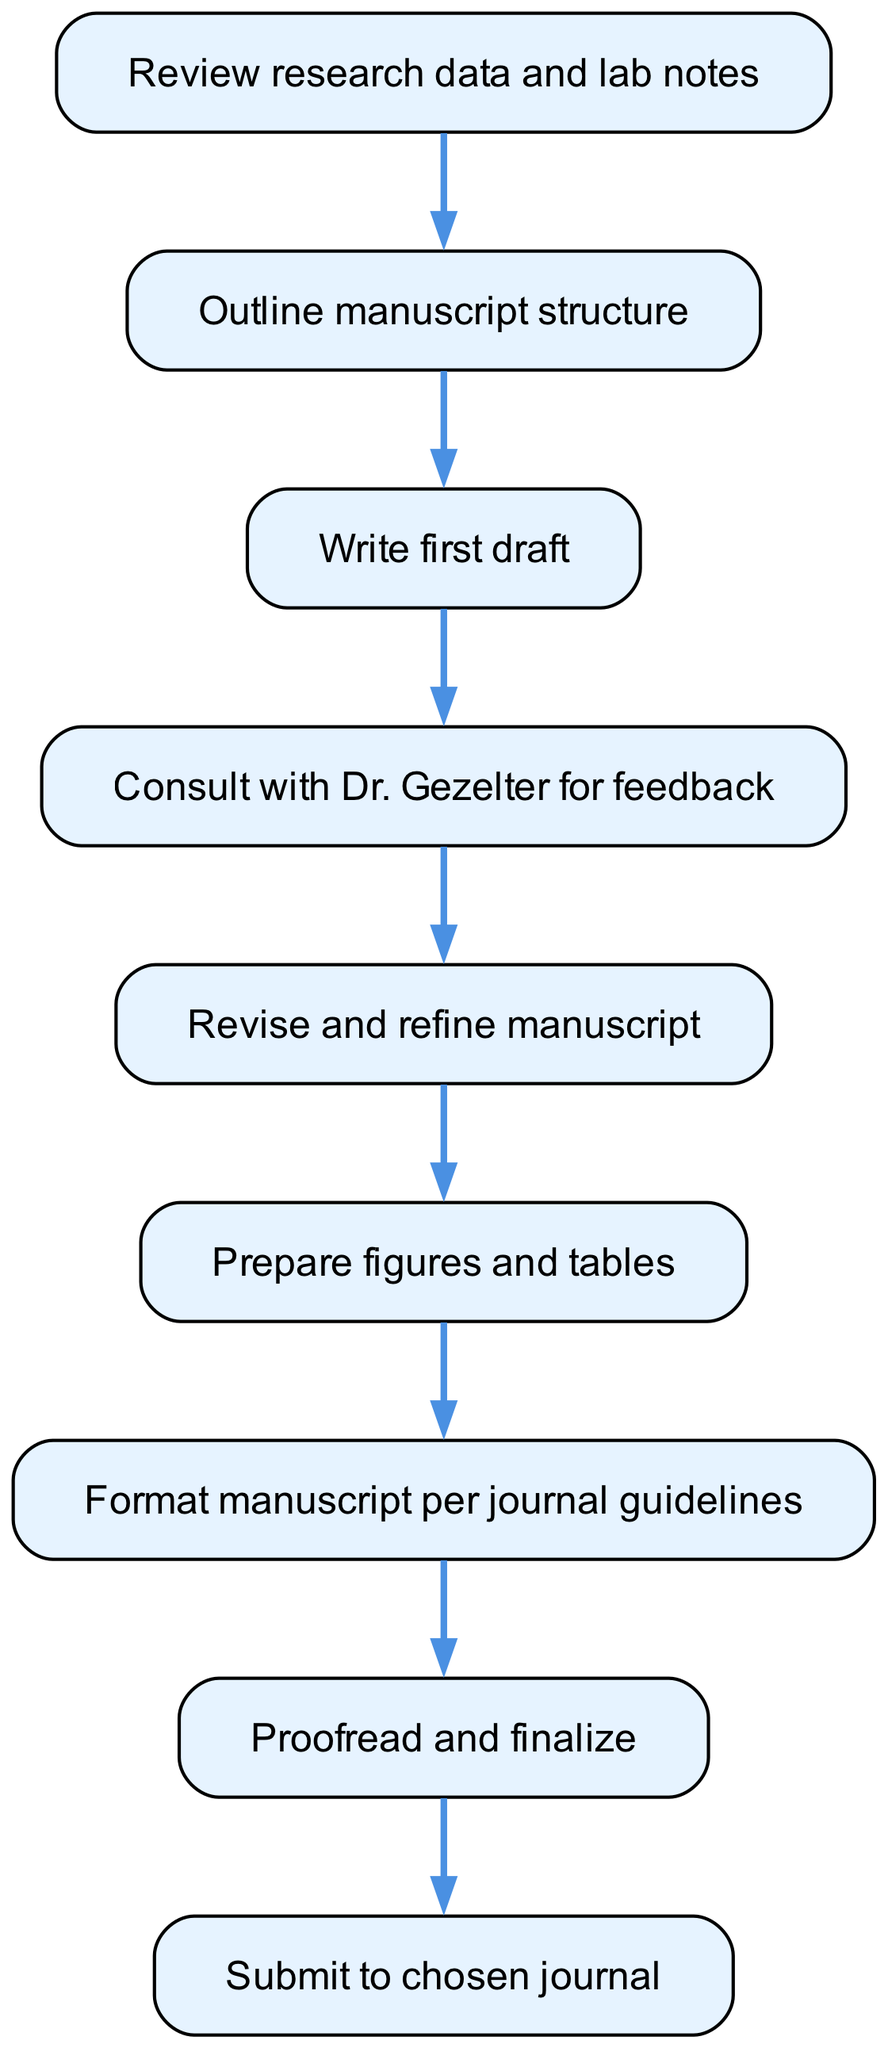What is the first step in the manuscript preparation process? The diagram clearly indicates that the first step is "Review research data and lab notes," as it is the first node in the flowchart.
Answer: Review research data and lab notes How many steps are there in total? Counting the nodes in the diagram, there are nine distinct steps outlined in the flowchart.
Answer: 9 What follows after Writing the first draft? In the flowchart, the step that directly follows "Write first draft" (step 3) is "Consult with Dr. Gezelter for feedback" (step 4), as indicated by the connecting edge.
Answer: Consult with Dr. Gezelter for feedback Which step immediately precedes the manuscript submission? According to the flowchart, the step that immediately precedes "Submit to chosen journal" (step 9) is "Proofread and finalize" (step 8), as shown in the connection between these two nodes.
Answer: Proofread and finalize What is the last step indicated in the diagram? The diagram indicates that the last step in the manuscript preparation is "Submit to chosen journal," which is the final node without any outgoing edges.
Answer: Submit to chosen journal How does the flowchart visualize the relationship between writing the first draft and receiving feedback? The flowchart shows a direct connection from "Write first draft" (step 3) to "Consult with Dr. Gezelter for feedback" (step 4), indicating that feedback is sought immediately after drafting.
Answer: Direct connection What is the penultimate step before formatting the manuscript? The penultimate step, which is the step just before "Format manuscript per journal guidelines" (step 7), is "Prepare figures and tables" (step 6), as shown in the sequence of the diagram.
Answer: Prepare figures and tables How many connections exist between the steps? By assessing the edges in the flowchart, we find that there are eight connections (edges) representing the flow from one step to the next.
Answer: 8 What is the primary focus of the fourth step in the manuscript preparation process? The fourth step, "Consult with Dr. Gezelter for feedback," indicates the primary focus is to seek feedback from a mentor or supervisor regarding the manuscript draft.
Answer: Seek feedback from Dr. Gezelter 